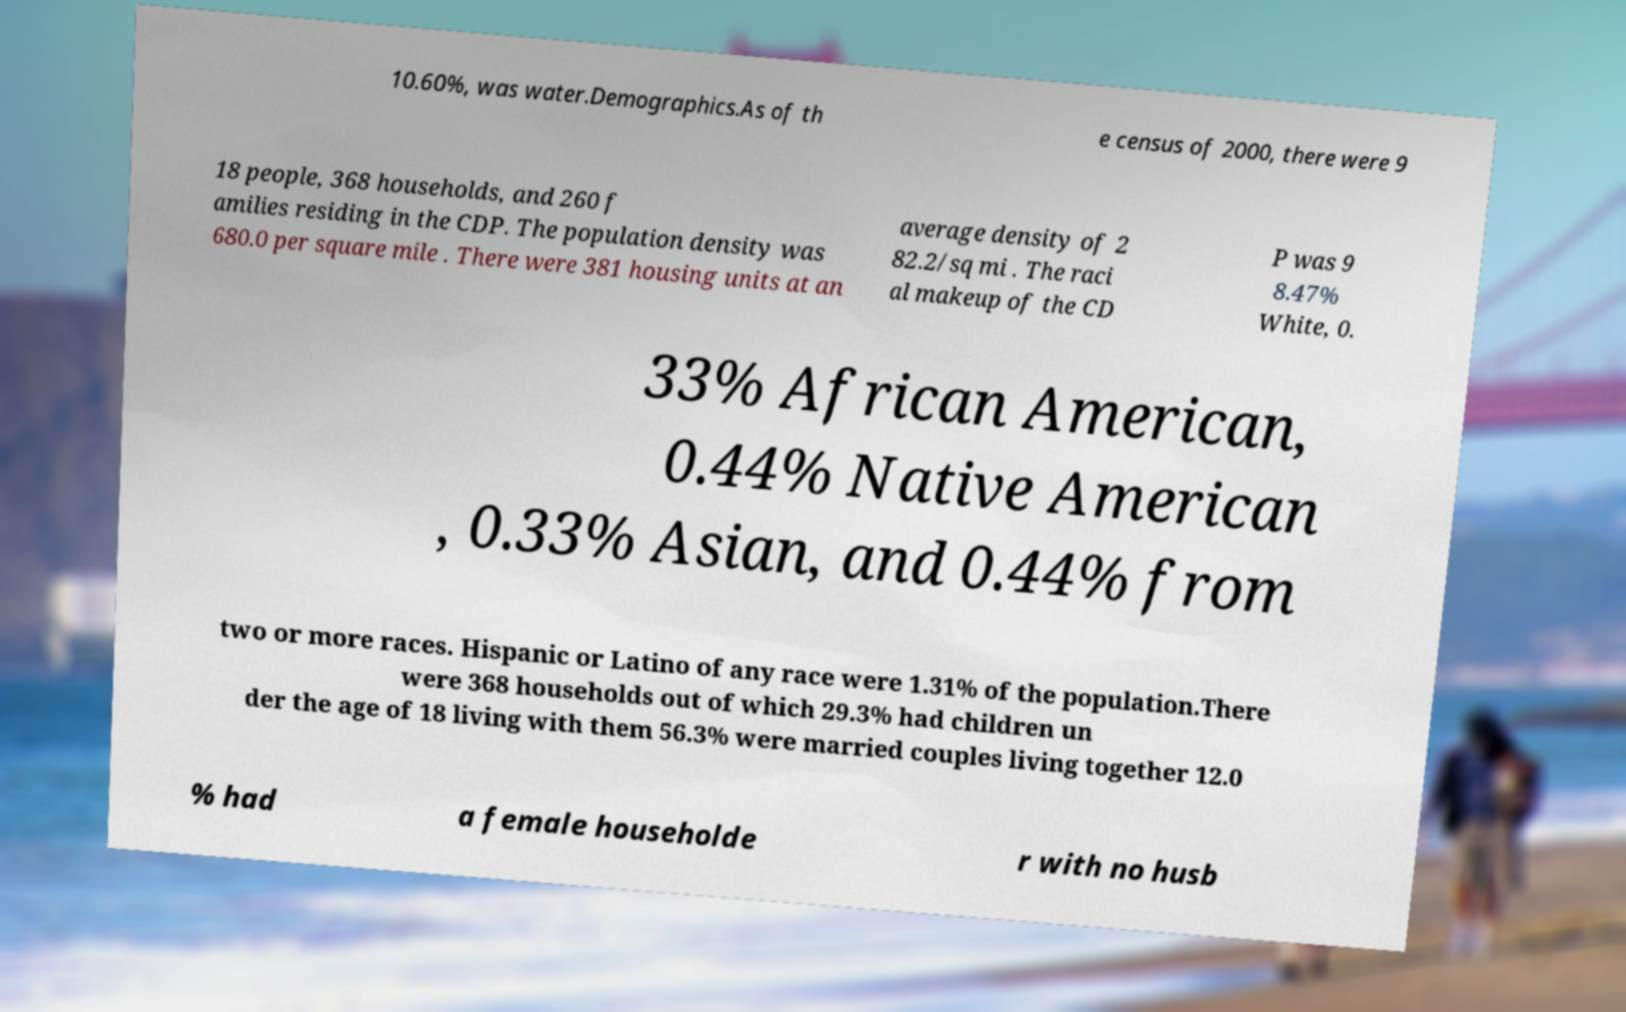Please identify and transcribe the text found in this image. 10.60%, was water.Demographics.As of th e census of 2000, there were 9 18 people, 368 households, and 260 f amilies residing in the CDP. The population density was 680.0 per square mile . There were 381 housing units at an average density of 2 82.2/sq mi . The raci al makeup of the CD P was 9 8.47% White, 0. 33% African American, 0.44% Native American , 0.33% Asian, and 0.44% from two or more races. Hispanic or Latino of any race were 1.31% of the population.There were 368 households out of which 29.3% had children un der the age of 18 living with them 56.3% were married couples living together 12.0 % had a female householde r with no husb 